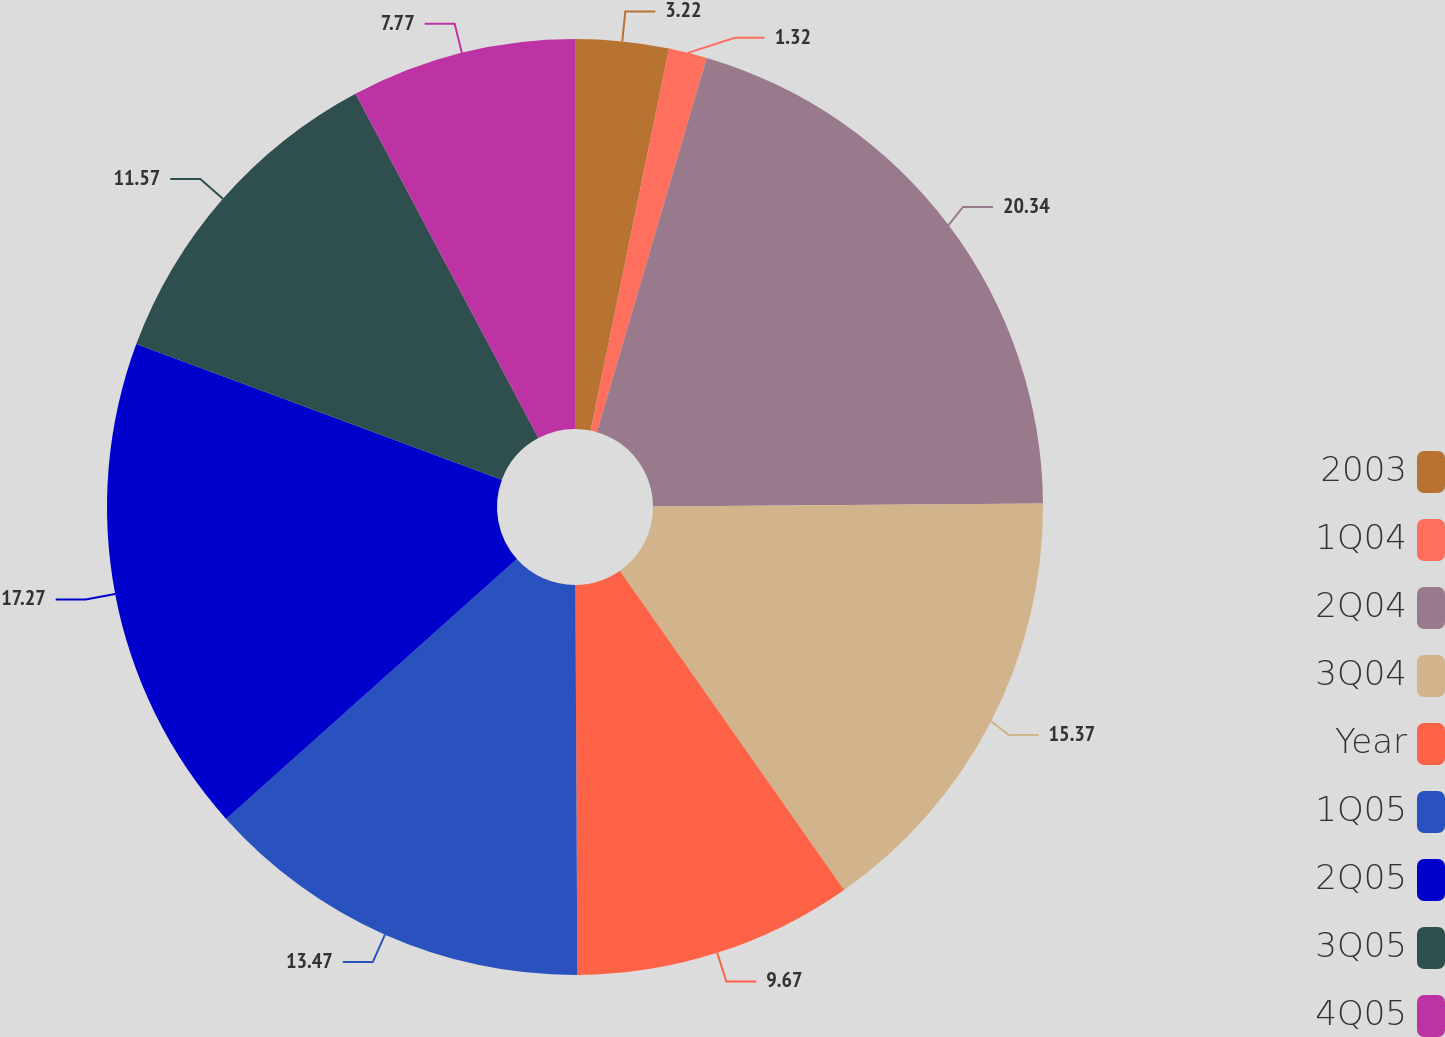Convert chart to OTSL. <chart><loc_0><loc_0><loc_500><loc_500><pie_chart><fcel>2003<fcel>1Q04<fcel>2Q04<fcel>3Q04<fcel>Year<fcel>1Q05<fcel>2Q05<fcel>3Q05<fcel>4Q05<nl><fcel>3.22%<fcel>1.32%<fcel>20.34%<fcel>15.37%<fcel>9.67%<fcel>13.47%<fcel>17.27%<fcel>11.57%<fcel>7.77%<nl></chart> 